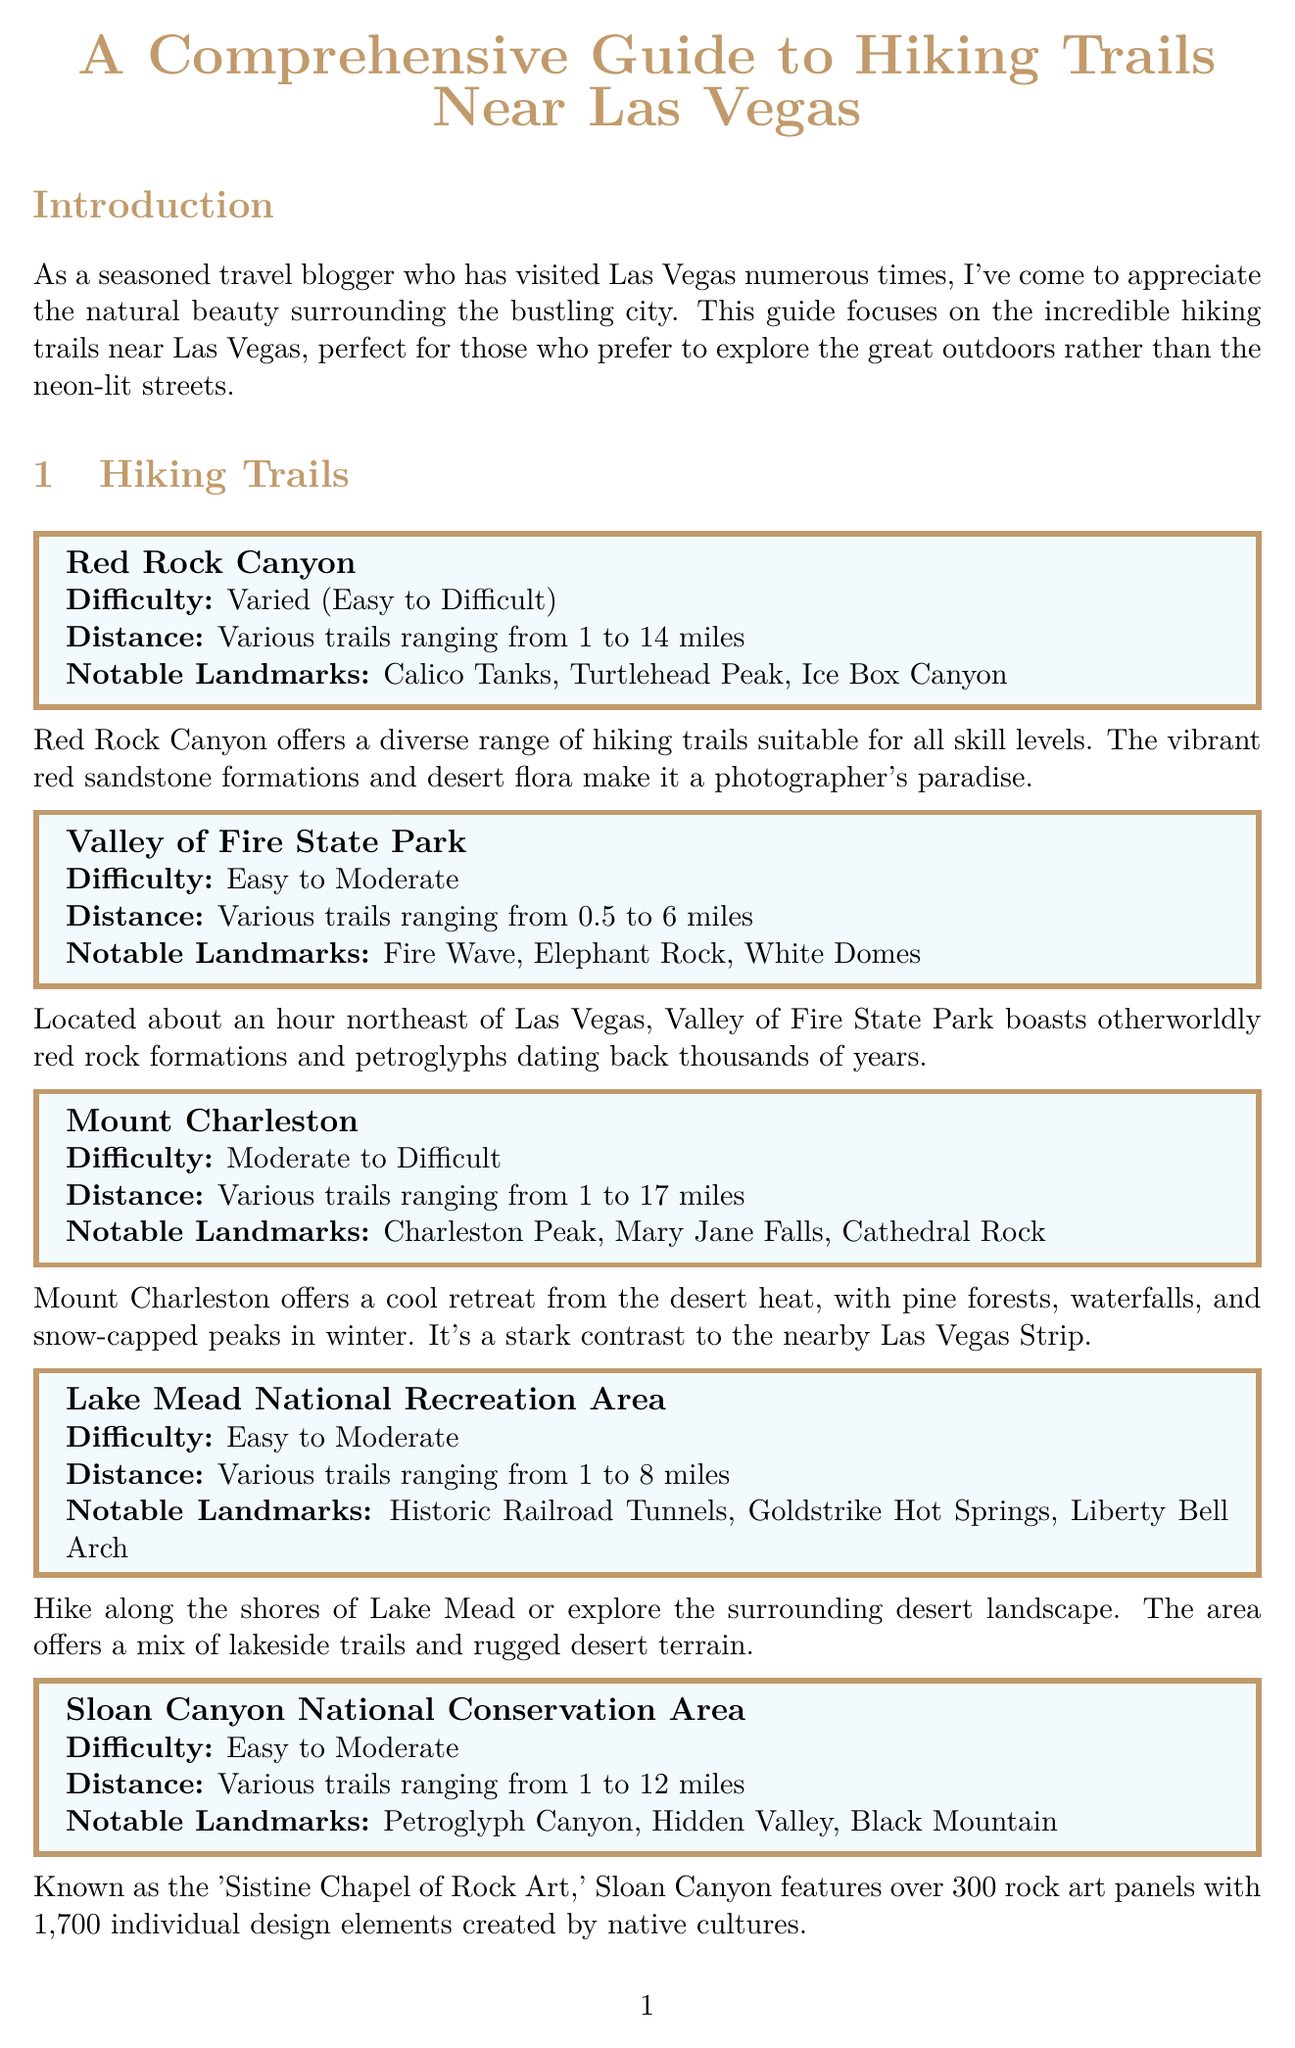what is the title of the guide? The title is stated at the beginning of the document as the main heading.
Answer: A Comprehensive Guide to Hiking Trails Near Las Vegas how many notable landmarks are listed for Lake Mead National Recreation Area? This information is found in the description of the Lake Mead National Recreation Area trail section.
Answer: 3 what is the difficulty level of the Mount Charleston trails? The difficulty levels can be found listed under the Mount Charleston trail section.
Answer: Moderate to Difficult which hiking trail features the 'Sistine Chapel of Rock Art'? This information is available in the description of Sloan Canyon National Conservation Area.
Answer: Sloan Canyon National Conservation Area what is the recommended water intake while hiking? This guideline can be found in the hiking tips section.
Answer: At least 1 liter per hour of hiking what is the best season for wildflower blooms? This is mentioned in the best seasons for hiking section regarding Spring.
Answer: March to May which landmark is associated with Valley of Fire State Park? This is noted in the notable landmarks for Valley of Fire State Park.
Answer: Fire Wave what is the distance range of the hiking trails in Red Rock Canyon? This information can be found in the distance section of the Red Rock Canyon trail description.
Answer: Various trails ranging from 1 to 14 miles 